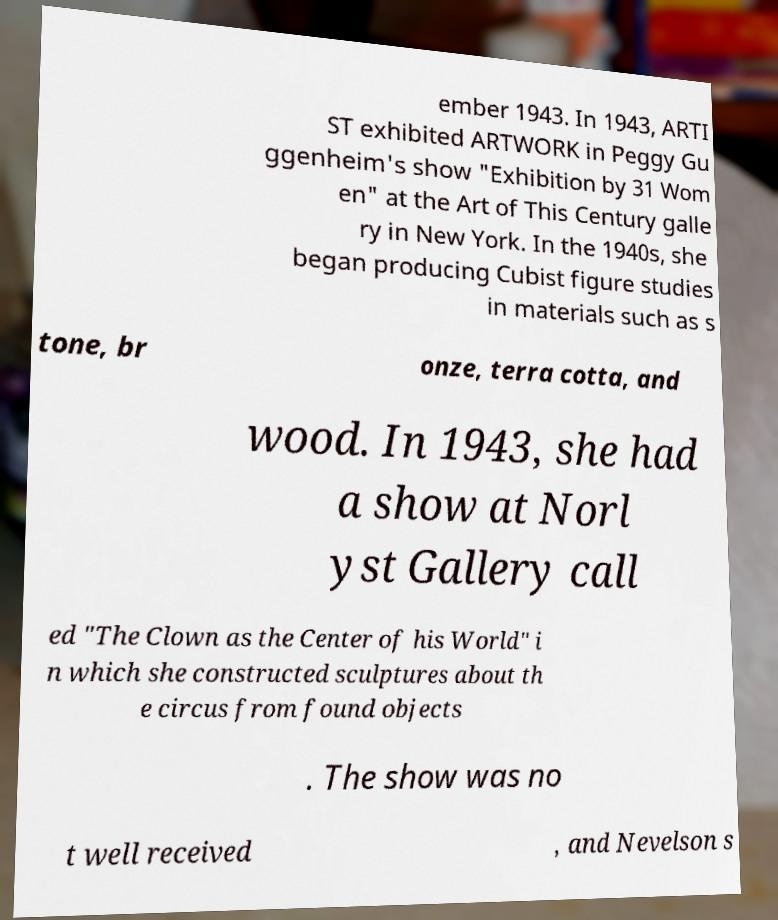There's text embedded in this image that I need extracted. Can you transcribe it verbatim? ember 1943. In 1943, ARTI ST exhibited ARTWORK in Peggy Gu ggenheim's show "Exhibition by 31 Wom en" at the Art of This Century galle ry in New York. In the 1940s, she began producing Cubist figure studies in materials such as s tone, br onze, terra cotta, and wood. In 1943, she had a show at Norl yst Gallery call ed "The Clown as the Center of his World" i n which she constructed sculptures about th e circus from found objects . The show was no t well received , and Nevelson s 